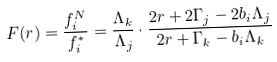<formula> <loc_0><loc_0><loc_500><loc_500>F ( r ) = \frac { f _ { i } ^ { N } } { f _ { i } ^ { * } } & = \frac { \Lambda _ { k } } { \Lambda _ { j } } \cdot \frac { 2 r + 2 \Gamma _ { j } - 2 b _ { i } \Lambda _ { j } } { 2 r + \Gamma _ { k } - b _ { i } \Lambda _ { k } } \\</formula> 